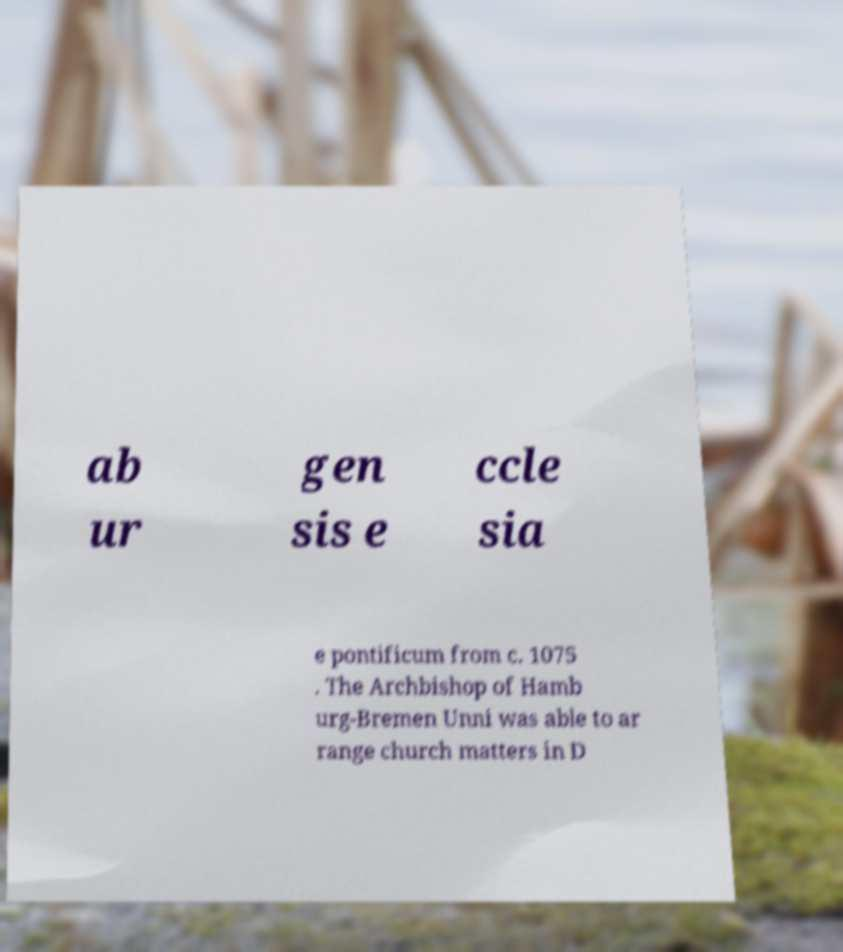Please read and relay the text visible in this image. What does it say? ab ur gen sis e ccle sia e pontificum from c. 1075 . The Archbishop of Hamb urg-Bremen Unni was able to ar range church matters in D 